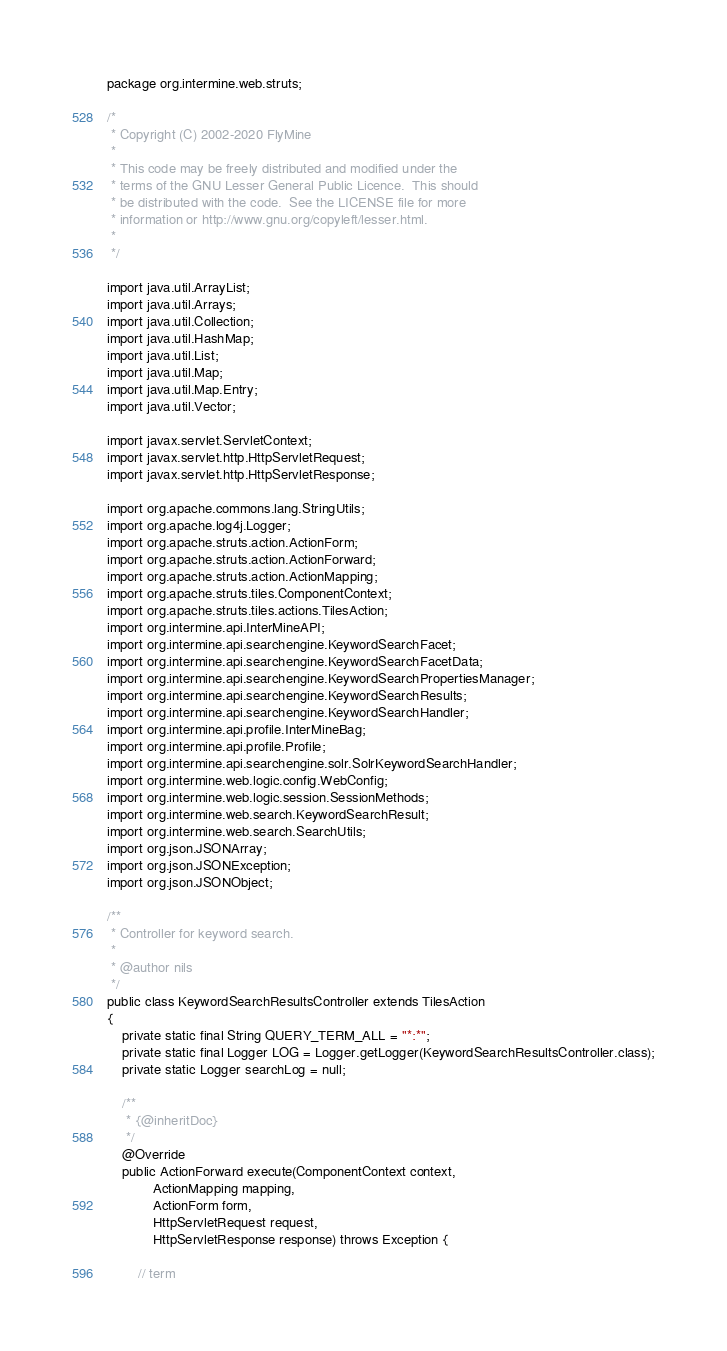Convert code to text. <code><loc_0><loc_0><loc_500><loc_500><_Java_>package org.intermine.web.struts;

/*
 * Copyright (C) 2002-2020 FlyMine
 *
 * This code may be freely distributed and modified under the
 * terms of the GNU Lesser General Public Licence.  This should
 * be distributed with the code.  See the LICENSE file for more
 * information or http://www.gnu.org/copyleft/lesser.html.
 *
 */

import java.util.ArrayList;
import java.util.Arrays;
import java.util.Collection;
import java.util.HashMap;
import java.util.List;
import java.util.Map;
import java.util.Map.Entry;
import java.util.Vector;

import javax.servlet.ServletContext;
import javax.servlet.http.HttpServletRequest;
import javax.servlet.http.HttpServletResponse;

import org.apache.commons.lang.StringUtils;
import org.apache.log4j.Logger;
import org.apache.struts.action.ActionForm;
import org.apache.struts.action.ActionForward;
import org.apache.struts.action.ActionMapping;
import org.apache.struts.tiles.ComponentContext;
import org.apache.struts.tiles.actions.TilesAction;
import org.intermine.api.InterMineAPI;
import org.intermine.api.searchengine.KeywordSearchFacet;
import org.intermine.api.searchengine.KeywordSearchFacetData;
import org.intermine.api.searchengine.KeywordSearchPropertiesManager;
import org.intermine.api.searchengine.KeywordSearchResults;
import org.intermine.api.searchengine.KeywordSearchHandler;
import org.intermine.api.profile.InterMineBag;
import org.intermine.api.profile.Profile;
import org.intermine.api.searchengine.solr.SolrKeywordSearchHandler;
import org.intermine.web.logic.config.WebConfig;
import org.intermine.web.logic.session.SessionMethods;
import org.intermine.web.search.KeywordSearchResult;
import org.intermine.web.search.SearchUtils;
import org.json.JSONArray;
import org.json.JSONException;
import org.json.JSONObject;

/**
 * Controller for keyword search.
 *
 * @author nils
 */
public class KeywordSearchResultsController extends TilesAction
{
    private static final String QUERY_TERM_ALL = "*:*";
    private static final Logger LOG = Logger.getLogger(KeywordSearchResultsController.class);
    private static Logger searchLog = null;

    /**
     * {@inheritDoc}
     */
    @Override
    public ActionForward execute(ComponentContext context,
            ActionMapping mapping,
            ActionForm form,
            HttpServletRequest request,
            HttpServletResponse response) throws Exception {

        // term</code> 